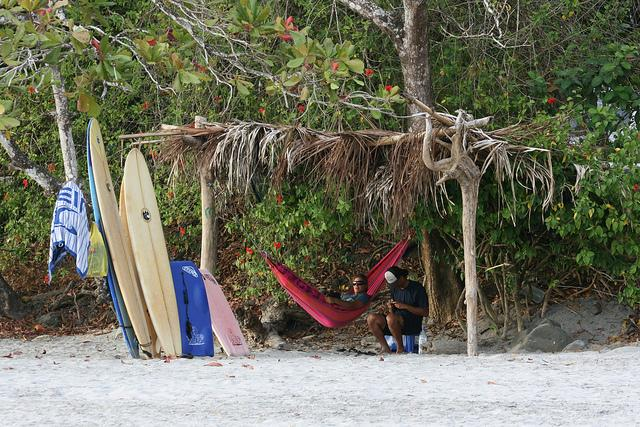What is the person sitting near?

Choices:
A) hens
B) cows
C) surfboards
D) slippers surfboards 